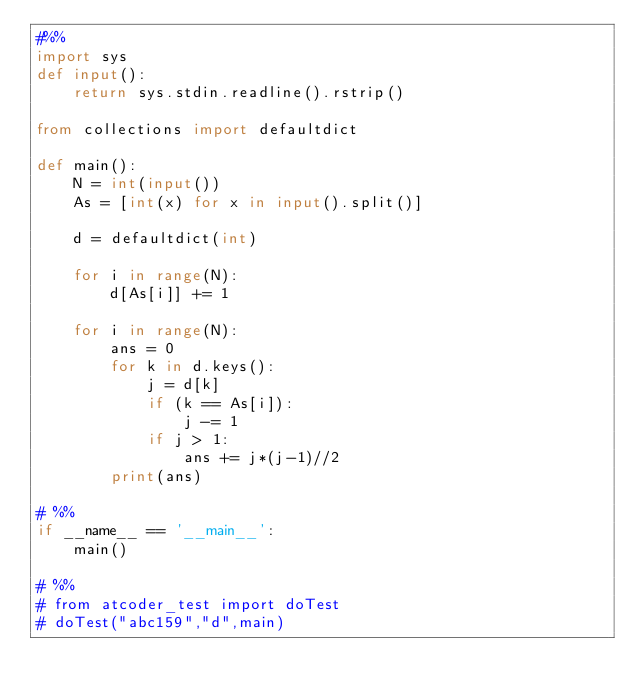Convert code to text. <code><loc_0><loc_0><loc_500><loc_500><_Python_>#%%
import sys
def input():
    return sys.stdin.readline().rstrip()

from collections import defaultdict

def main():
    N = int(input())
    As = [int(x) for x in input().split()]

    d = defaultdict(int)

    for i in range(N):
        d[As[i]] += 1
    
    for i in range(N):
        ans = 0
        for k in d.keys():
            j = d[k]
            if (k == As[i]):
                j -= 1
            if j > 1:
                ans += j*(j-1)//2
        print(ans)

# %%
if __name__ == '__main__':
    main()

# %%
# from atcoder_test import doTest
# doTest("abc159","d",main)</code> 